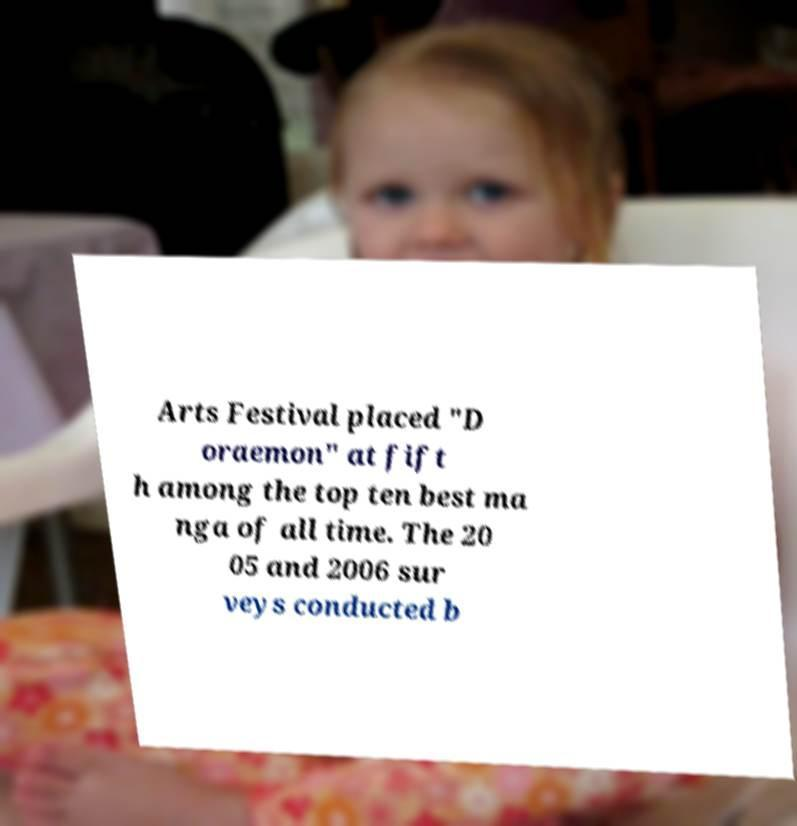I need the written content from this picture converted into text. Can you do that? Arts Festival placed "D oraemon" at fift h among the top ten best ma nga of all time. The 20 05 and 2006 sur veys conducted b 